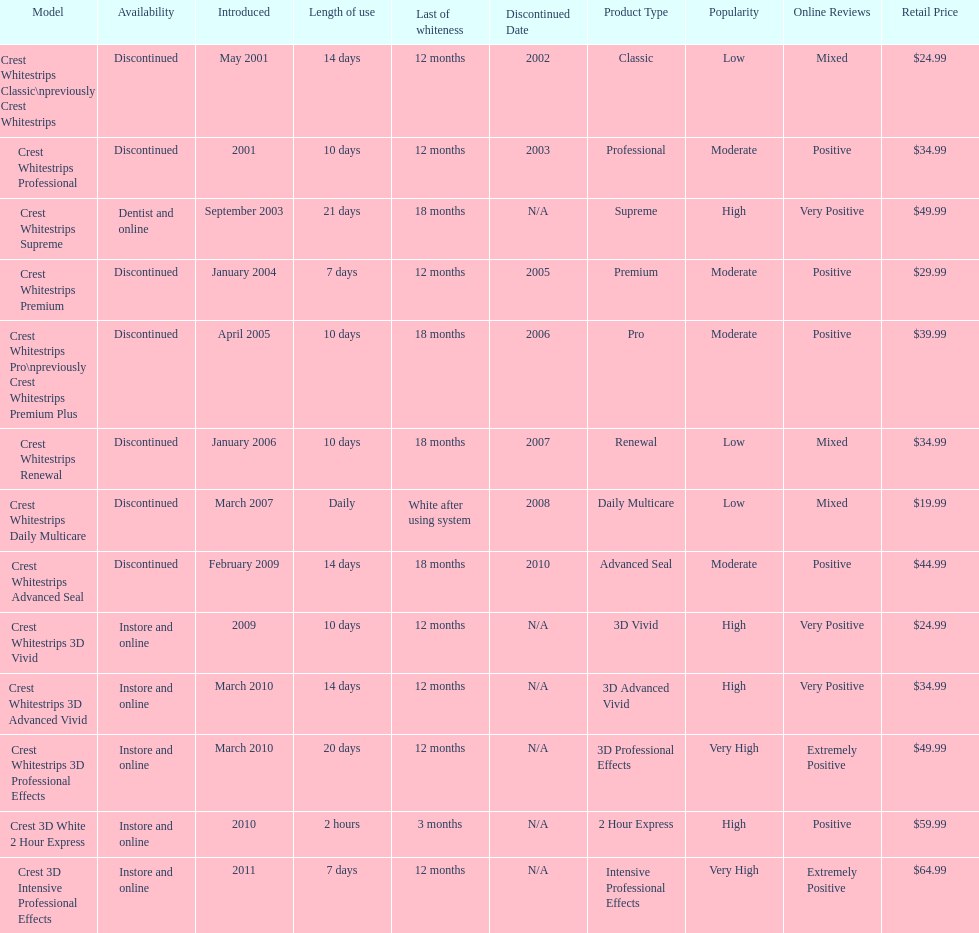Would you be able to parse every entry in this table? {'header': ['Model', 'Availability', 'Introduced', 'Length of use', 'Last of whiteness', 'Discontinued Date', 'Product Type', 'Popularity', 'Online Reviews', 'Retail Price'], 'rows': [['Crest Whitestrips Classic\\npreviously Crest Whitestrips', 'Discontinued', 'May 2001', '14 days', '12 months', '2002', 'Classic', 'Low', 'Mixed', '$24.99'], ['Crest Whitestrips Professional', 'Discontinued', '2001', '10 days', '12 months', '2003', 'Professional', 'Moderate', 'Positive', '$34.99'], ['Crest Whitestrips Supreme', 'Dentist and online', 'September 2003', '21 days', '18 months', 'N/A', 'Supreme', 'High', 'Very Positive', '$49.99'], ['Crest Whitestrips Premium', 'Discontinued', 'January 2004', '7 days', '12 months', '2005', 'Premium', 'Moderate', 'Positive', '$29.99'], ['Crest Whitestrips Pro\\npreviously Crest Whitestrips Premium Plus', 'Discontinued', 'April 2005', '10 days', '18 months', '2006', 'Pro', 'Moderate', 'Positive', '$39.99'], ['Crest Whitestrips Renewal', 'Discontinued', 'January 2006', '10 days', '18 months', '2007', 'Renewal', 'Low', 'Mixed', '$34.99'], ['Crest Whitestrips Daily Multicare', 'Discontinued', 'March 2007', 'Daily', 'White after using system', '2008', 'Daily Multicare', 'Low', 'Mixed', '$19.99'], ['Crest Whitestrips Advanced Seal', 'Discontinued', 'February 2009', '14 days', '18 months', '2010', 'Advanced Seal', 'Moderate', 'Positive', '$44.99'], ['Crest Whitestrips 3D Vivid', 'Instore and online', '2009', '10 days', '12 months', 'N/A', '3D Vivid', 'High', 'Very Positive', '$24.99'], ['Crest Whitestrips 3D Advanced Vivid', 'Instore and online', 'March 2010', '14 days', '12 months', 'N/A', '3D Advanced Vivid', 'High', 'Very Positive', '$34.99'], ['Crest Whitestrips 3D Professional Effects', 'Instore and online', 'March 2010', '20 days', '12 months', 'N/A', '3D Professional Effects', 'Very High', 'Extremely Positive', '$49.99'], ['Crest 3D White 2 Hour Express', 'Instore and online', '2010', '2 hours', '3 months', 'N/A', '2 Hour Express', 'High', 'Positive', '$59.99'], ['Crest 3D Intensive Professional Effects', 'Instore and online', '2011', '7 days', '12 months', 'N/A', 'Intensive Professional Effects', 'Very High', 'Extremely Positive', '$64.99']]} What is the number of products that were introduced in 2010? 3. 